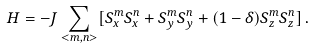<formula> <loc_0><loc_0><loc_500><loc_500>H = - J \sum _ { < m , n > } [ S _ { x } ^ { m } S _ { x } ^ { n } + S _ { y } ^ { m } S _ { y } ^ { n } + ( 1 - \delta ) S _ { z } ^ { m } S _ { z } ^ { n } ] \, .</formula> 